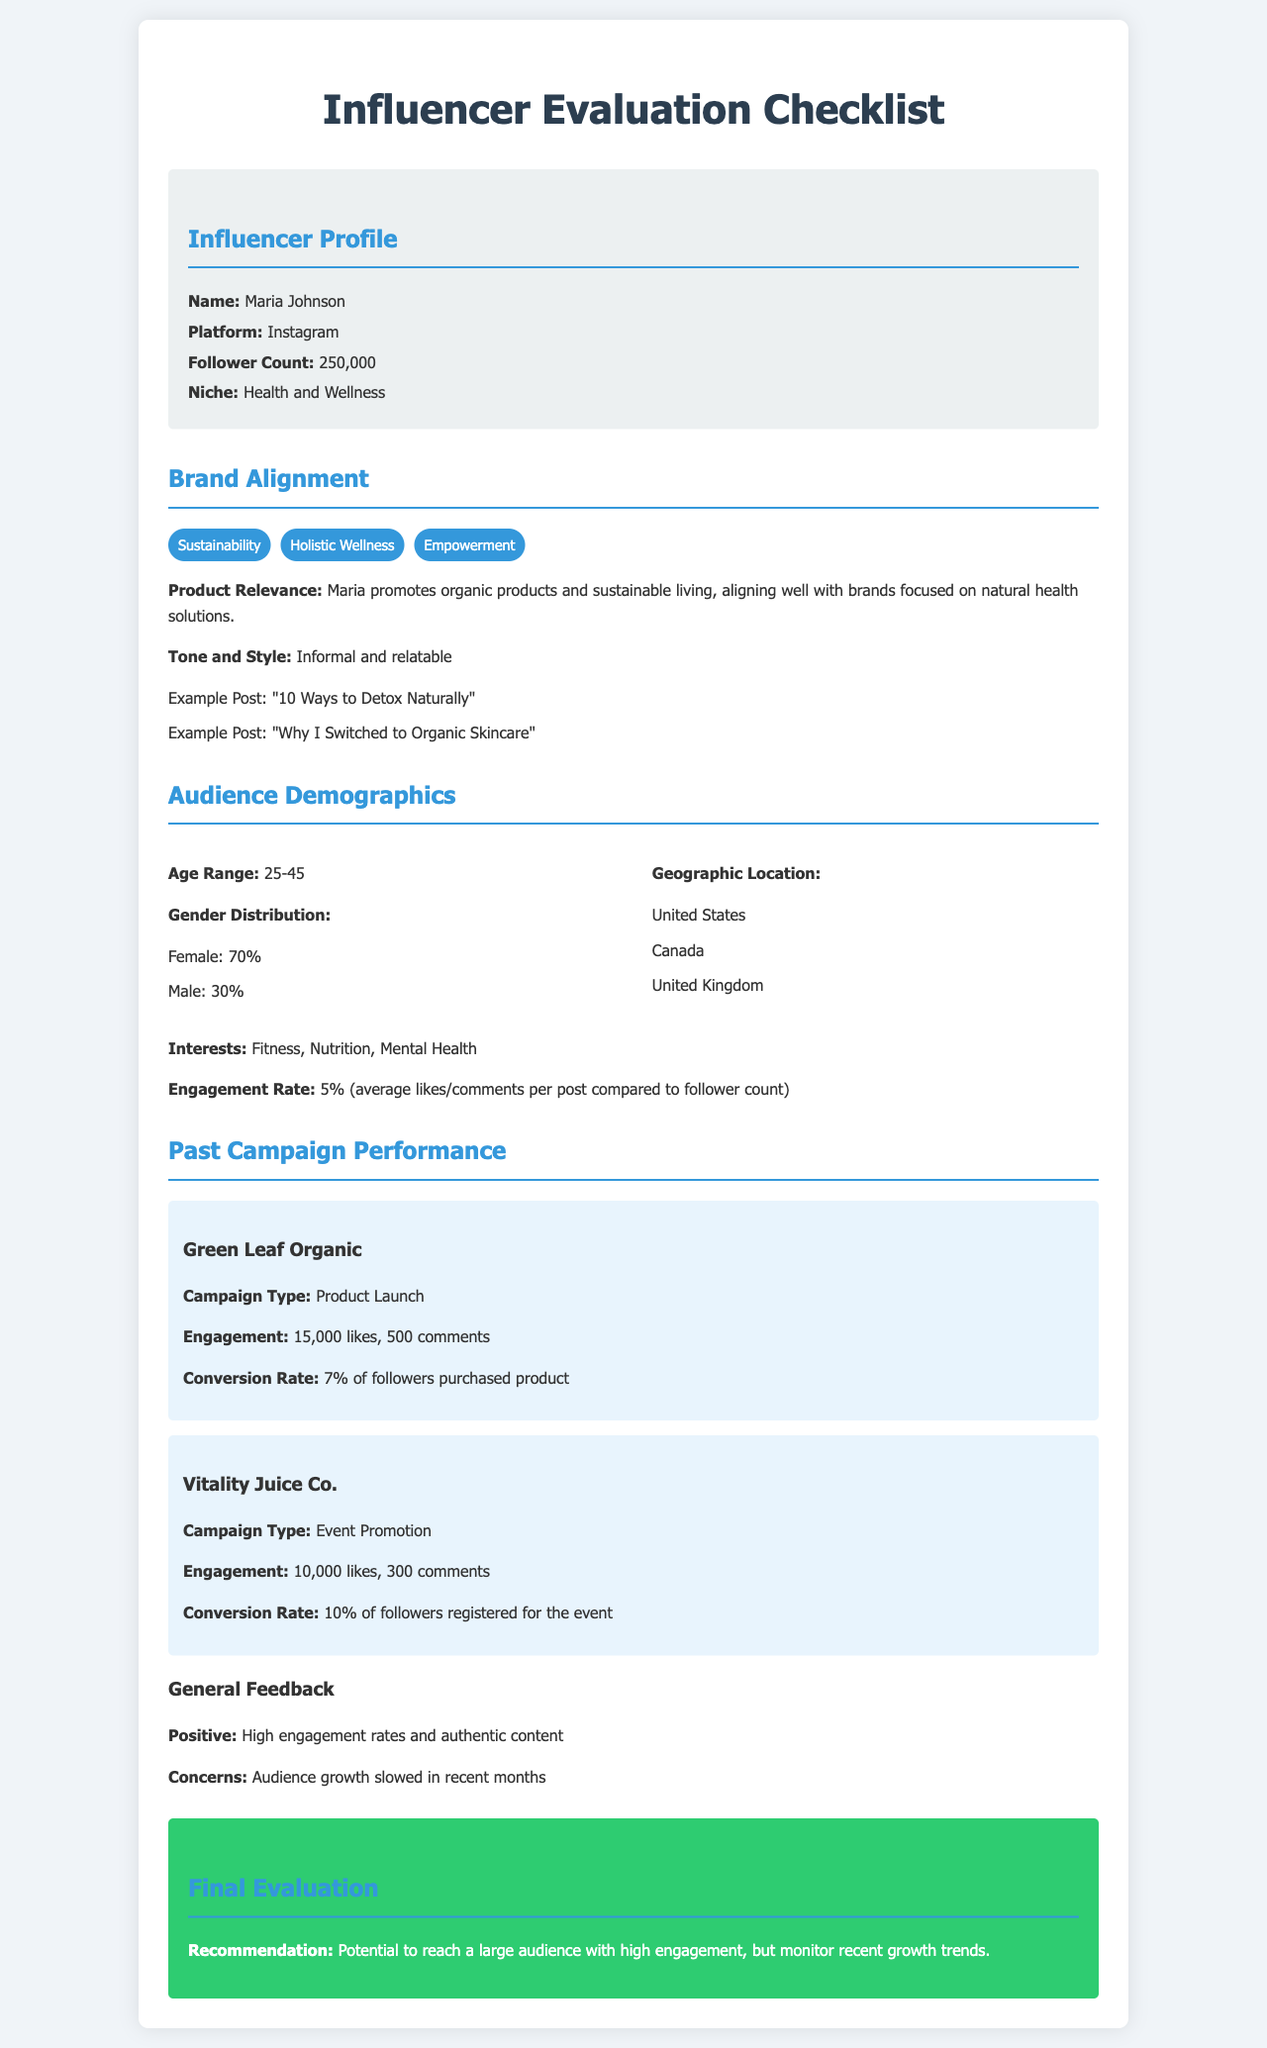What is the influencer's name? The influencer's name is listed in the profile section of the document.
Answer: Maria Johnson What is the follower count? The follower count is specified under the influencer profile as a numeric value.
Answer: 250,000 What are the age range demographics of the audience? The age range demographic is specified in the audience demographics section of the checklist.
Answer: 25-45 What percentage of the audience is female? The gender distribution is listed, and the percentage of female followers is provided.
Answer: 70% What was the engagement for the Green Leaf Organic campaign? The engagement metrics for the Green Leaf Organic campaign are stated in the past campaign performance section.
Answer: 15,000 likes, 500 comments What is the engagement rate for the influencer? The engagement rate is detailed in the audience demographics section, calculated based on likes and comments.
Answer: 5% What are Maria's brand values? The brand values are presented in a list format in the brand alignment section.
Answer: Sustainability, Holistic Wellness, Empowerment What was the conversion rate for the Vitality Juice Co. campaign? The conversion rate for the Vitality Juice Co. campaign is explicitly mentioned in the document.
Answer: 10% What is the recommendation in the final evaluation? The recommendation is provided in the final evaluation section and summarizes the assessment.
Answer: Potential to reach a large audience with high engagement, but monitor recent growth trends 